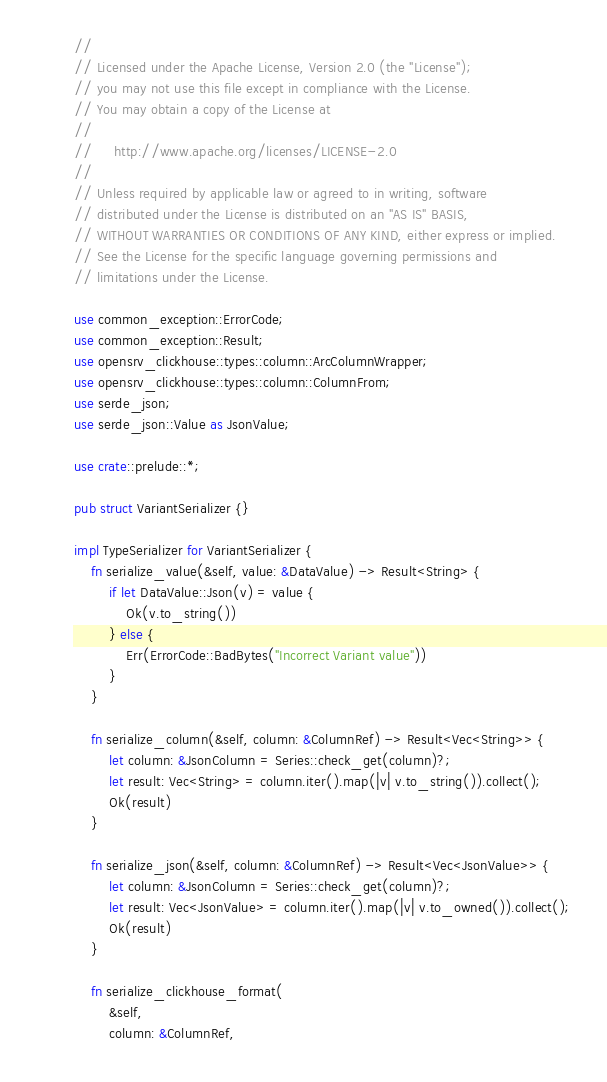<code> <loc_0><loc_0><loc_500><loc_500><_Rust_>//
// Licensed under the Apache License, Version 2.0 (the "License");
// you may not use this file except in compliance with the License.
// You may obtain a copy of the License at
//
//     http://www.apache.org/licenses/LICENSE-2.0
//
// Unless required by applicable law or agreed to in writing, software
// distributed under the License is distributed on an "AS IS" BASIS,
// WITHOUT WARRANTIES OR CONDITIONS OF ANY KIND, either express or implied.
// See the License for the specific language governing permissions and
// limitations under the License.

use common_exception::ErrorCode;
use common_exception::Result;
use opensrv_clickhouse::types::column::ArcColumnWrapper;
use opensrv_clickhouse::types::column::ColumnFrom;
use serde_json;
use serde_json::Value as JsonValue;

use crate::prelude::*;

pub struct VariantSerializer {}

impl TypeSerializer for VariantSerializer {
    fn serialize_value(&self, value: &DataValue) -> Result<String> {
        if let DataValue::Json(v) = value {
            Ok(v.to_string())
        } else {
            Err(ErrorCode::BadBytes("Incorrect Variant value"))
        }
    }

    fn serialize_column(&self, column: &ColumnRef) -> Result<Vec<String>> {
        let column: &JsonColumn = Series::check_get(column)?;
        let result: Vec<String> = column.iter().map(|v| v.to_string()).collect();
        Ok(result)
    }

    fn serialize_json(&self, column: &ColumnRef) -> Result<Vec<JsonValue>> {
        let column: &JsonColumn = Series::check_get(column)?;
        let result: Vec<JsonValue> = column.iter().map(|v| v.to_owned()).collect();
        Ok(result)
    }

    fn serialize_clickhouse_format(
        &self,
        column: &ColumnRef,</code> 